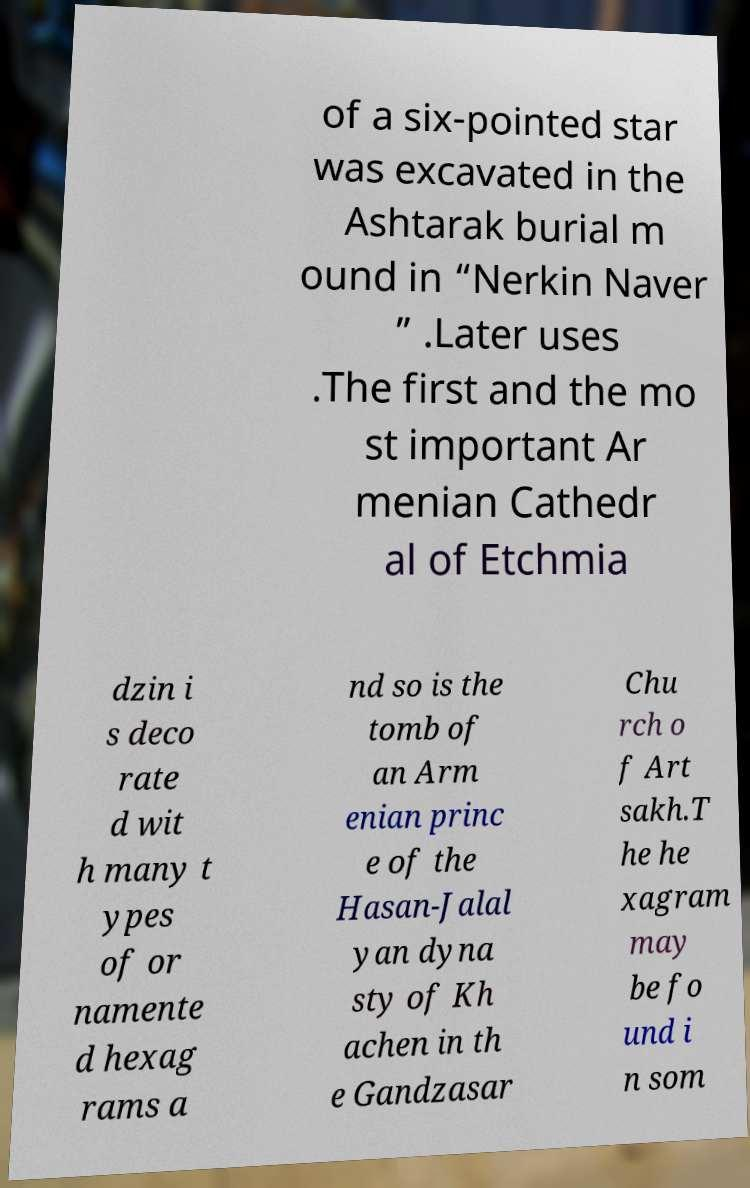Can you accurately transcribe the text from the provided image for me? of a six-pointed star was excavated in the Ashtarak burial m ound in “Nerkin Naver ” .Later uses .The first and the mo st important Ar menian Cathedr al of Etchmia dzin i s deco rate d wit h many t ypes of or namente d hexag rams a nd so is the tomb of an Arm enian princ e of the Hasan-Jalal yan dyna sty of Kh achen in th e Gandzasar Chu rch o f Art sakh.T he he xagram may be fo und i n som 